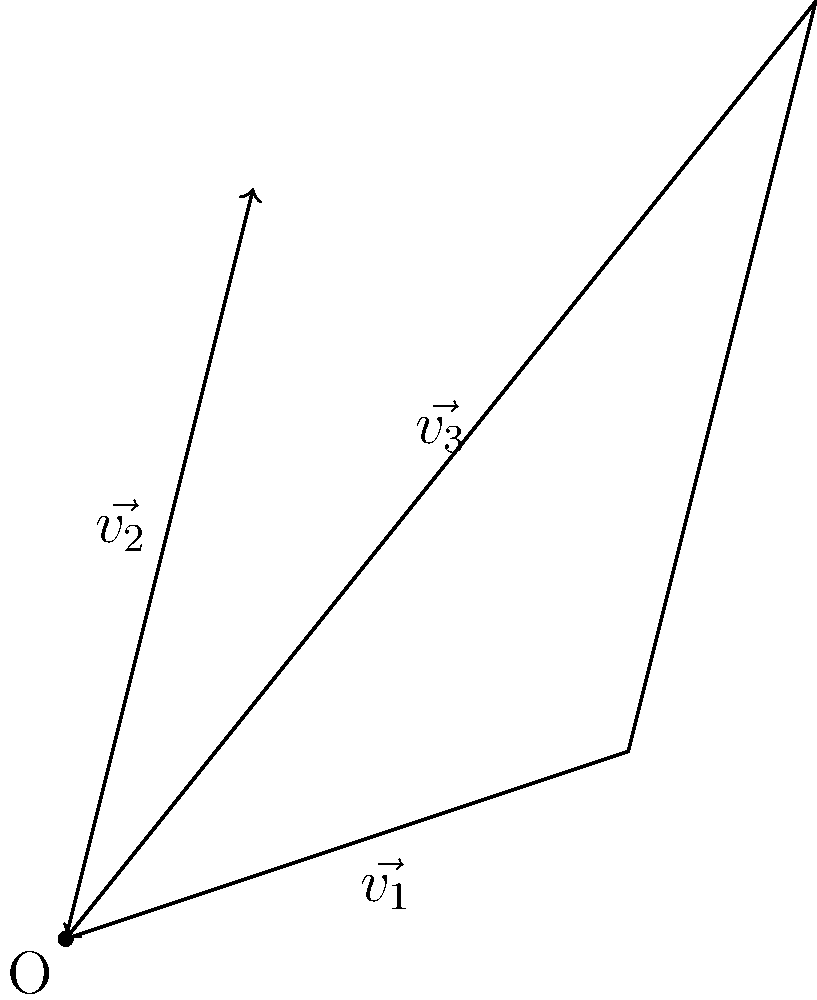As a costume designer for Teen Titans cosplay, you're combining elements from different character outfits to create a unique design. Each element is represented by a vector. Given $\vec{v_1} = 3\hat{i} + \hat{j}$, $\vec{v_2} = \hat{i} + 4\hat{j}$, and $\vec{v_3}$ as shown in the diagram, what is the magnitude of $\vec{v_3}$? To find the magnitude of $\vec{v_3}$, we can use vector addition and the properties of right triangles. Let's approach this step-by-step:

1) We know that $\vec{v_3} = \vec{v_1} + \vec{v_2}$

2) From the diagram, we can see that $\vec{v_3}$ forms the hypotenuse of a right triangle with $\vec{v_1}$ and $\vec{v_2}$ as its other sides.

3) To find the components of $\vec{v_3}$:
   x-component: $3 + 1 = 4$
   y-component: $1 + 4 = 5$

4) So, $\vec{v_3} = 4\hat{i} + 5\hat{j}$

5) To find the magnitude, we use the Pythagorean theorem:
   $|\vec{v_3}| = \sqrt{(4)^2 + (5)^2}$

6) Simplify:
   $|\vec{v_3}| = \sqrt{16 + 25} = \sqrt{41}$

Therefore, the magnitude of $\vec{v_3}$ is $\sqrt{41}$ units.
Answer: $\sqrt{41}$ 